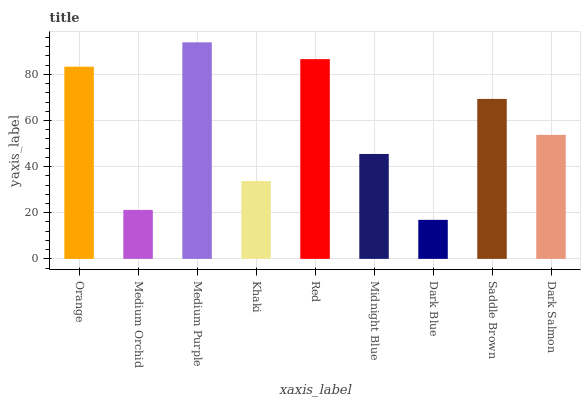Is Medium Orchid the minimum?
Answer yes or no. No. Is Medium Orchid the maximum?
Answer yes or no. No. Is Orange greater than Medium Orchid?
Answer yes or no. Yes. Is Medium Orchid less than Orange?
Answer yes or no. Yes. Is Medium Orchid greater than Orange?
Answer yes or no. No. Is Orange less than Medium Orchid?
Answer yes or no. No. Is Dark Salmon the high median?
Answer yes or no. Yes. Is Dark Salmon the low median?
Answer yes or no. Yes. Is Saddle Brown the high median?
Answer yes or no. No. Is Midnight Blue the low median?
Answer yes or no. No. 